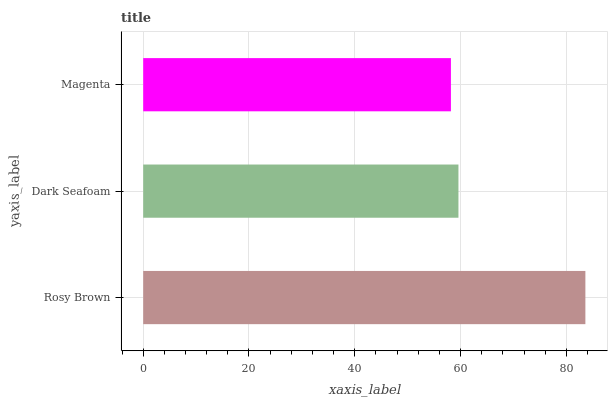Is Magenta the minimum?
Answer yes or no. Yes. Is Rosy Brown the maximum?
Answer yes or no. Yes. Is Dark Seafoam the minimum?
Answer yes or no. No. Is Dark Seafoam the maximum?
Answer yes or no. No. Is Rosy Brown greater than Dark Seafoam?
Answer yes or no. Yes. Is Dark Seafoam less than Rosy Brown?
Answer yes or no. Yes. Is Dark Seafoam greater than Rosy Brown?
Answer yes or no. No. Is Rosy Brown less than Dark Seafoam?
Answer yes or no. No. Is Dark Seafoam the high median?
Answer yes or no. Yes. Is Dark Seafoam the low median?
Answer yes or no. Yes. Is Rosy Brown the high median?
Answer yes or no. No. Is Magenta the low median?
Answer yes or no. No. 